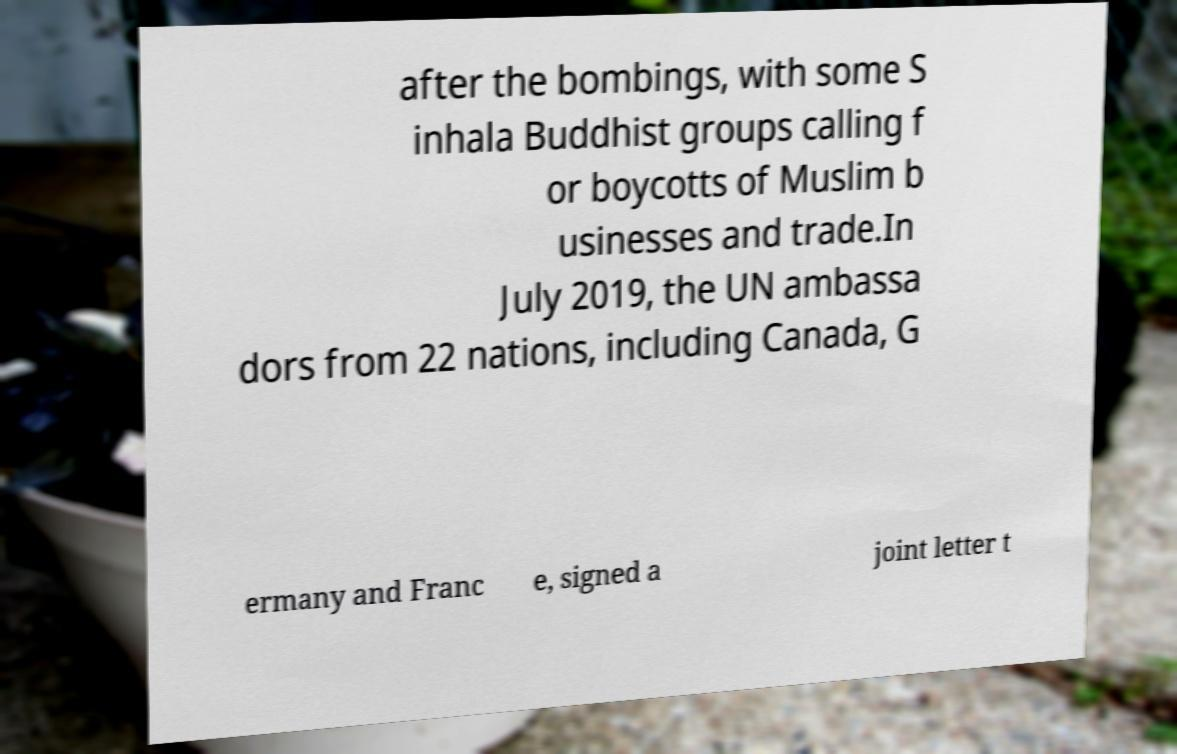Could you extract and type out the text from this image? after the bombings, with some S inhala Buddhist groups calling f or boycotts of Muslim b usinesses and trade.In July 2019, the UN ambassa dors from 22 nations, including Canada, G ermany and Franc e, signed a joint letter t 